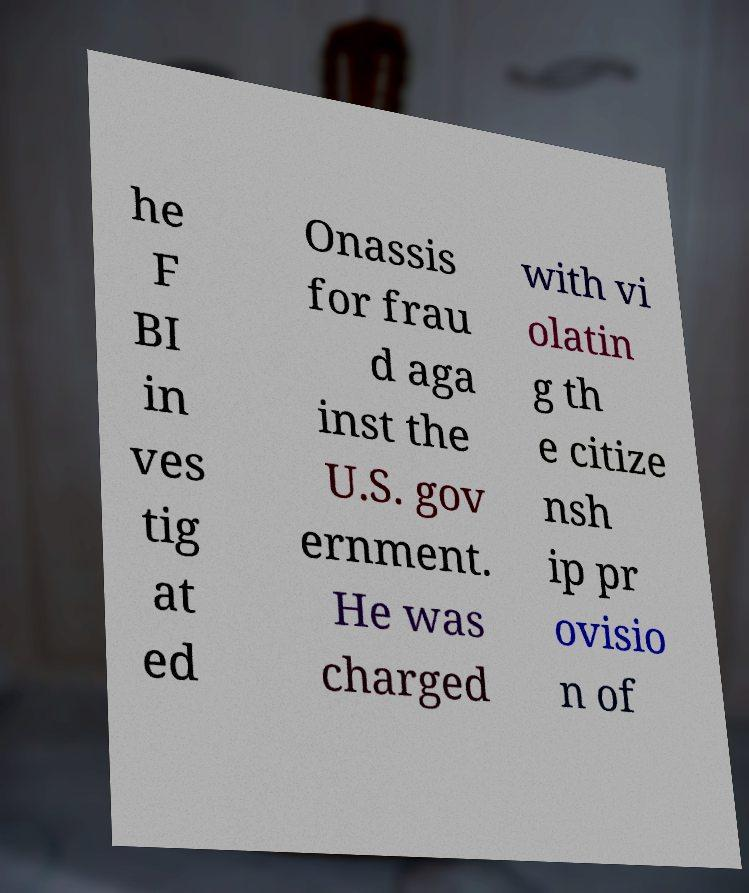Please identify and transcribe the text found in this image. he F BI in ves tig at ed Onassis for frau d aga inst the U.S. gov ernment. He was charged with vi olatin g th e citize nsh ip pr ovisio n of 